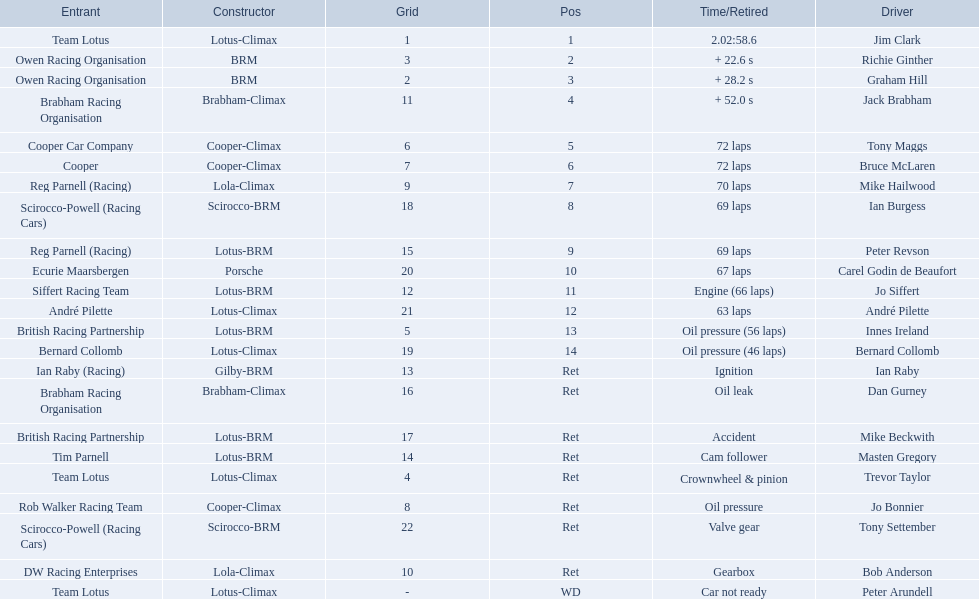Who are all the drivers? Jim Clark, Richie Ginther, Graham Hill, Jack Brabham, Tony Maggs, Bruce McLaren, Mike Hailwood, Ian Burgess, Peter Revson, Carel Godin de Beaufort, Jo Siffert, André Pilette, Innes Ireland, Bernard Collomb, Ian Raby, Dan Gurney, Mike Beckwith, Masten Gregory, Trevor Taylor, Jo Bonnier, Tony Settember, Bob Anderson, Peter Arundell. What were their positions? 1, 2, 3, 4, 5, 6, 7, 8, 9, 10, 11, 12, 13, 14, Ret, Ret, Ret, Ret, Ret, Ret, Ret, Ret, WD. What are all the constructor names? Lotus-Climax, BRM, BRM, Brabham-Climax, Cooper-Climax, Cooper-Climax, Lola-Climax, Scirocco-BRM, Lotus-BRM, Porsche, Lotus-BRM, Lotus-Climax, Lotus-BRM, Lotus-Climax, Gilby-BRM, Brabham-Climax, Lotus-BRM, Lotus-BRM, Lotus-Climax, Cooper-Climax, Scirocco-BRM, Lola-Climax, Lotus-Climax. And which drivers drove a cooper-climax? Tony Maggs, Bruce McLaren. Between those tow, who was positioned higher? Tony Maggs. 